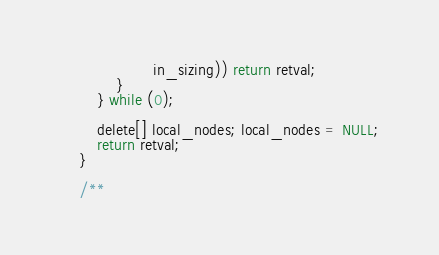<code> <loc_0><loc_0><loc_500><loc_500><_Cuda_>                    in_sizing)) return retval;
            }
        } while (0);

        delete[] local_nodes; local_nodes = NULL;
        return retval;
    }

    /**</code> 